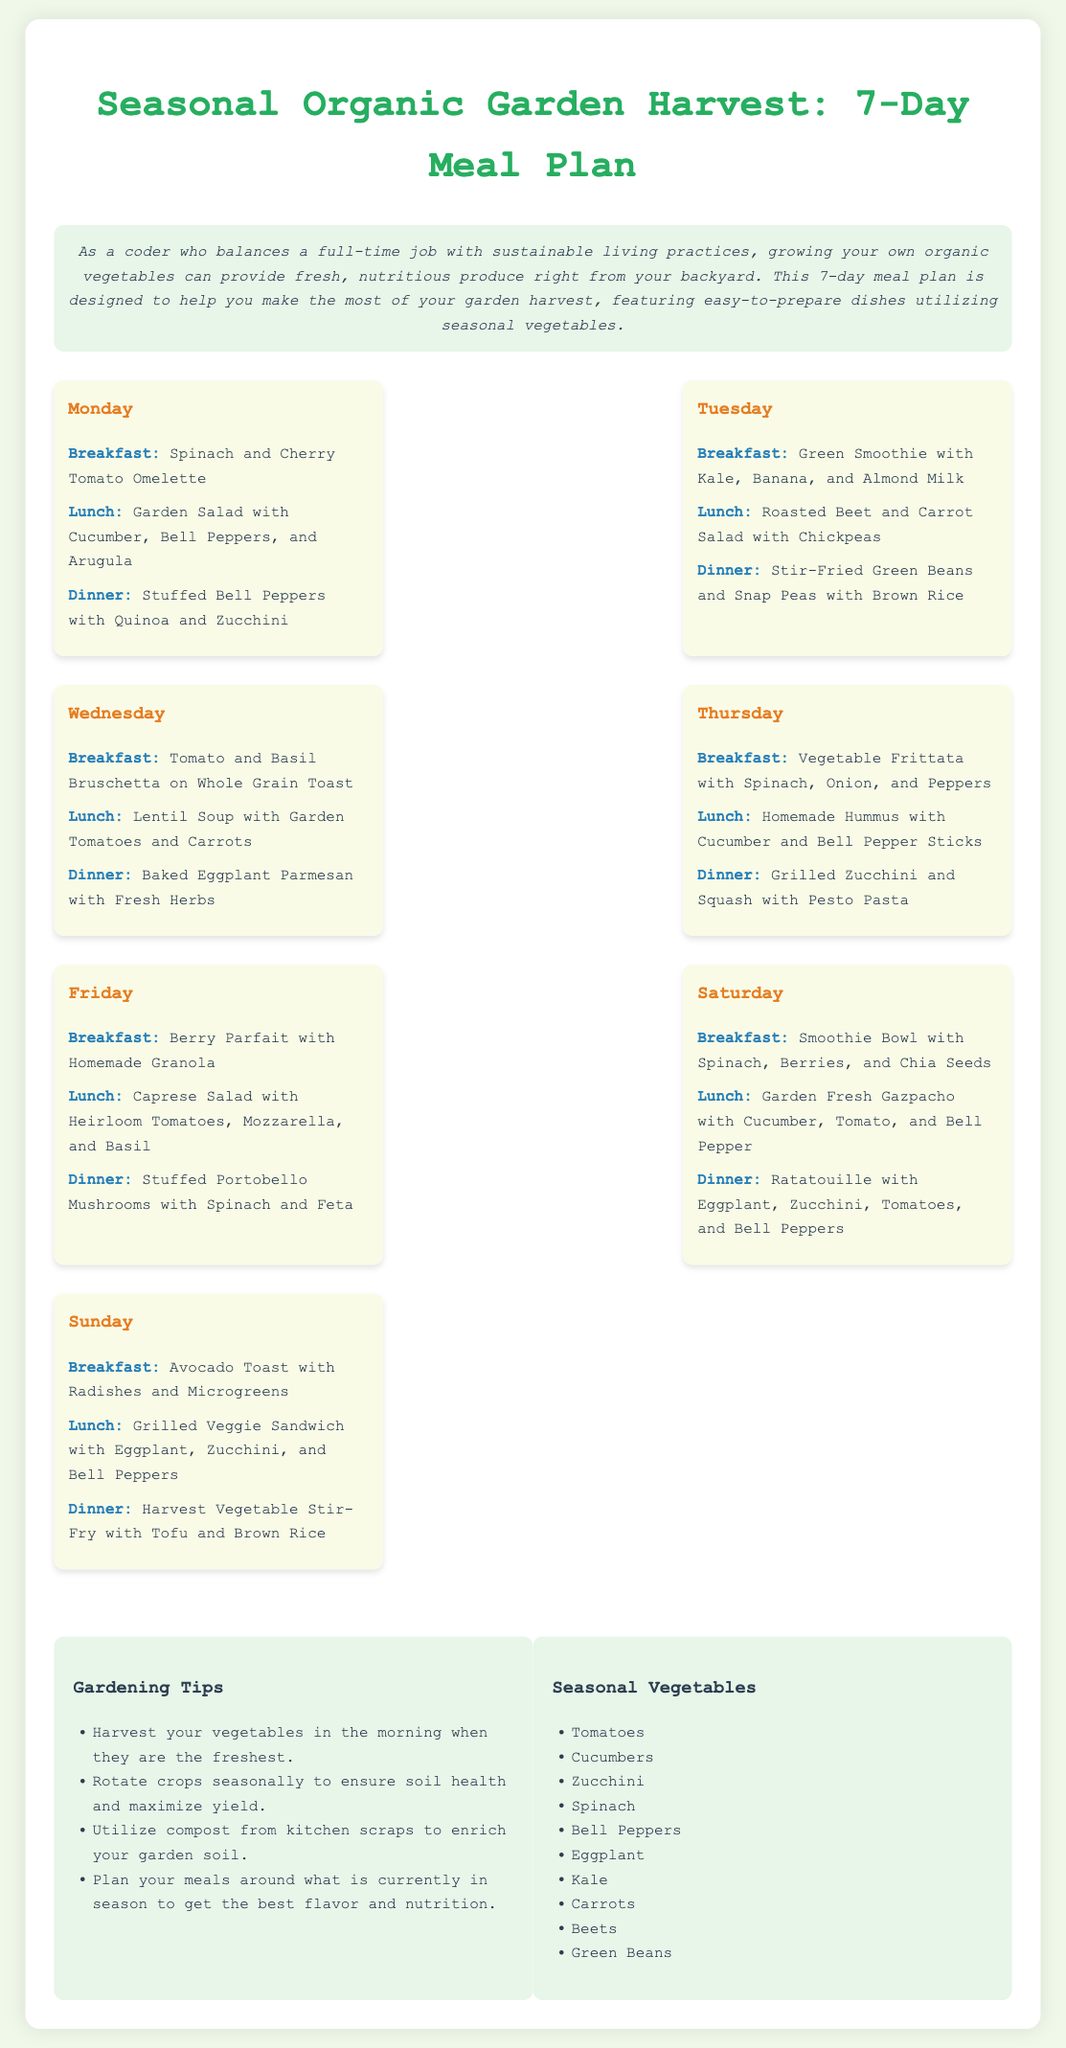What is the title of the meal plan? The title of the meal plan is prominently displayed at the top of the document.
Answer: Seasonal Organic Garden Harvest: 7-Day Meal Plan What dish is served for breakfast on Wednesday? The breakfast for Wednesday is listed under the day section.
Answer: Tomato and Basil Bruschetta on Whole Grain Toast How many meals are suggested for each day? The document structure shows that three meals are provided for each day of the week.
Answer: Three Which vegetable is featured in the breakfast on Sunday? The Sunday breakfast includes details that specifically mention the vegetable used.
Answer: Avocado What is one gardening tip mentioned in the document? The document lists several gardening tips, one of which is outlined under the tips section.
Answer: Harvest your vegetables in the morning when they are the freshest Which meal on Friday includes cheese? The meals are listed, and the one mentioning cheese can be identified from the Friday section.
Answer: Caprese Salad with Heirloom Tomatoes, Mozzarella, and Basil What type of salad is served for lunch on Tuesday? The lunch for Tuesday is specifically identified in the meal plan section.
Answer: Roasted Beet and Carrot Salad with Chickpeas 